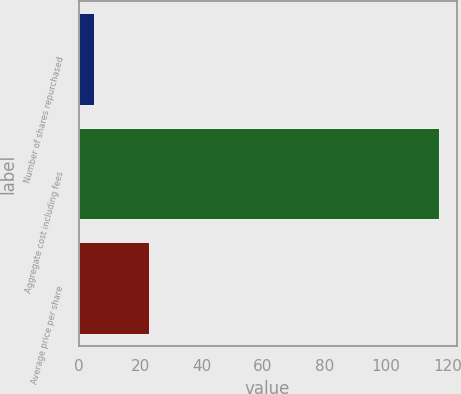Convert chart to OTSL. <chart><loc_0><loc_0><loc_500><loc_500><bar_chart><fcel>Number of shares repurchased<fcel>Aggregate cost including fees<fcel>Average price per share<nl><fcel>5.1<fcel>117.1<fcel>23.03<nl></chart> 